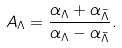<formula> <loc_0><loc_0><loc_500><loc_500>A _ { \Lambda } = \frac { \alpha _ { \Lambda } + \alpha _ { \bar { \Lambda } } } { \alpha _ { \Lambda } - \alpha _ { \bar { \Lambda } } } .</formula> 